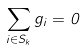<formula> <loc_0><loc_0><loc_500><loc_500>\sum _ { i \in S _ { k } } g _ { i } = 0</formula> 